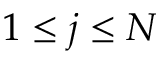Convert formula to latex. <formula><loc_0><loc_0><loc_500><loc_500>1 \leq j \leq N</formula> 